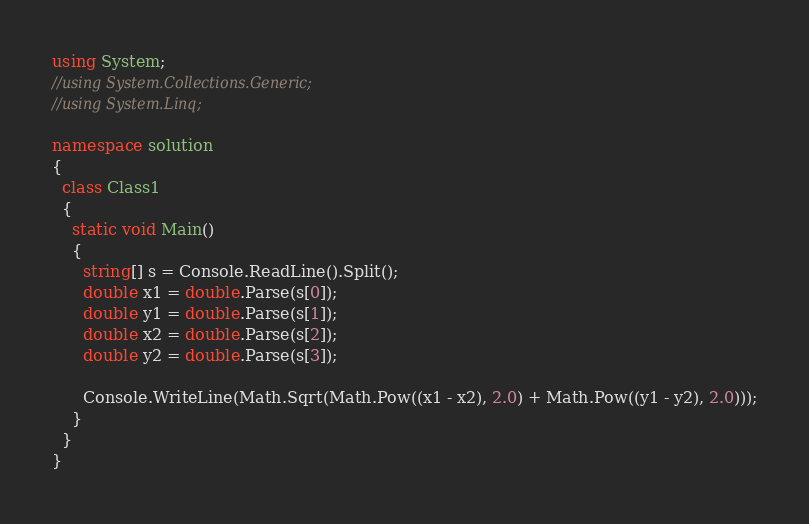Convert code to text. <code><loc_0><loc_0><loc_500><loc_500><_C#_>using System;
//using System.Collections.Generic;
//using System.Linq;

namespace solution
{
  class Class1
  {
    static void Main()
    {
      string[] s = Console.ReadLine().Split();
      double x1 = double.Parse(s[0]);
      double y1 = double.Parse(s[1]);
      double x2 = double.Parse(s[2]);
      double y2 = double.Parse(s[3]);

      Console.WriteLine(Math.Sqrt(Math.Pow((x1 - x2), 2.0) + Math.Pow((y1 - y2), 2.0)));
    }
  }
}
</code> 